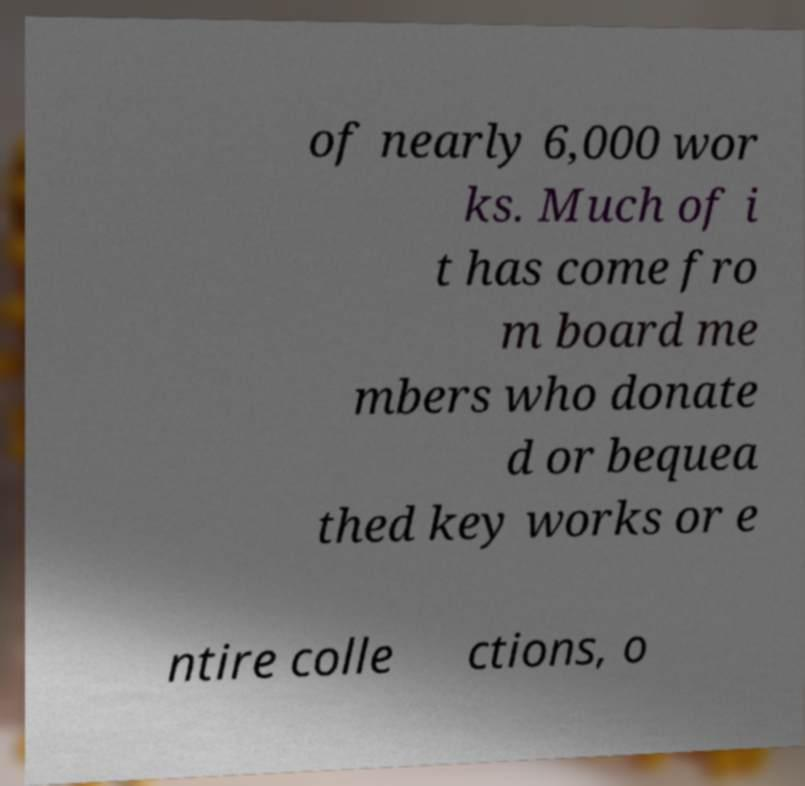Please identify and transcribe the text found in this image. of nearly 6,000 wor ks. Much of i t has come fro m board me mbers who donate d or bequea thed key works or e ntire colle ctions, o 